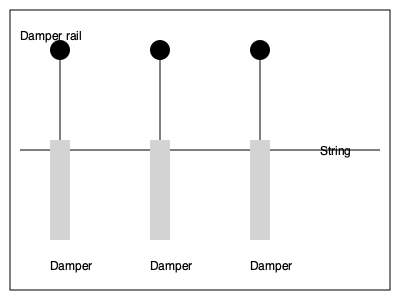In the diagram of a piano's damper system, what is the primary function of the damper rail, and how does it contribute to the pianist's ability to control volume? 1. The damper rail is the horizontal line at the top of the diagram, connecting all the damper mechanisms.

2. Each vertical line represents a damper lever, which is connected to the damper rail at the top.

3. The damper rail moves up and down, controlling all dampers simultaneously:
   a) When the rail is up, all dampers are lifted off the strings.
   b) When the rail is down, dampers rest on the strings.

4. The damper rail is connected to the piano's sustain pedal:
   a) Pressing the pedal lifts the rail, raising all dampers.
   b) Releasing the pedal lowers the rail, allowing dampers to contact strings.

5. This system allows for:
   a) Sustaining notes when the pedal is pressed.
   b) Stopping vibrations quickly when the pedal is released.

6. Volume control:
   a) The speed and force of the damper's return to the string affects the abruptness of note termination.
   b) Gradual pedal release allows for smoother, quieter note endings.
   c) Quick pedal release results in more sudden, potentially louder note endings.

7. For a pianist focused on low volume playing:
   a) Careful, gradual pedal control allows for soft note endings.
   b) Precise timing of pedal release in relation to key release helps maintain lower volumes.

Therefore, the damper rail system is crucial for a pianist to control sustain and, indirectly, contribute to volume management, especially for those prioritizing softer playing.
Answer: The damper rail simultaneously controls all dampers, allowing the pianist to manage sustain and indirectly influence volume through pedal technique. 